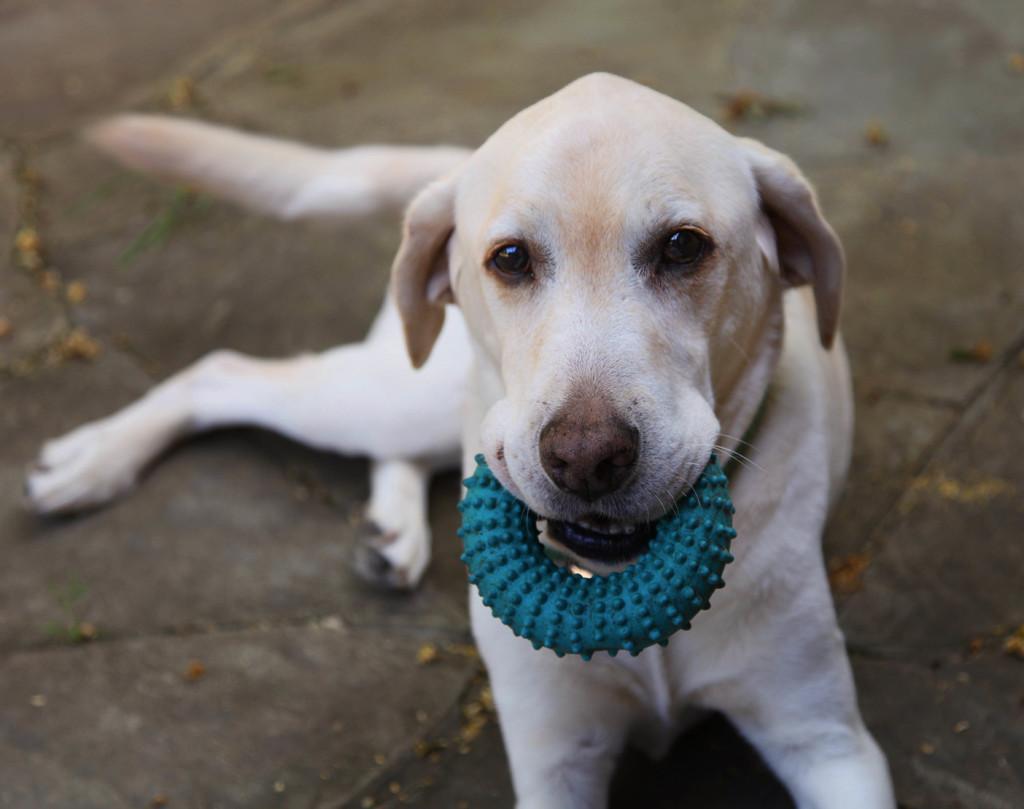Please provide a concise description of this image. In this image in the front there is a dog sitting on the ground. On the neck of the dog there is an object which is green in colour. 